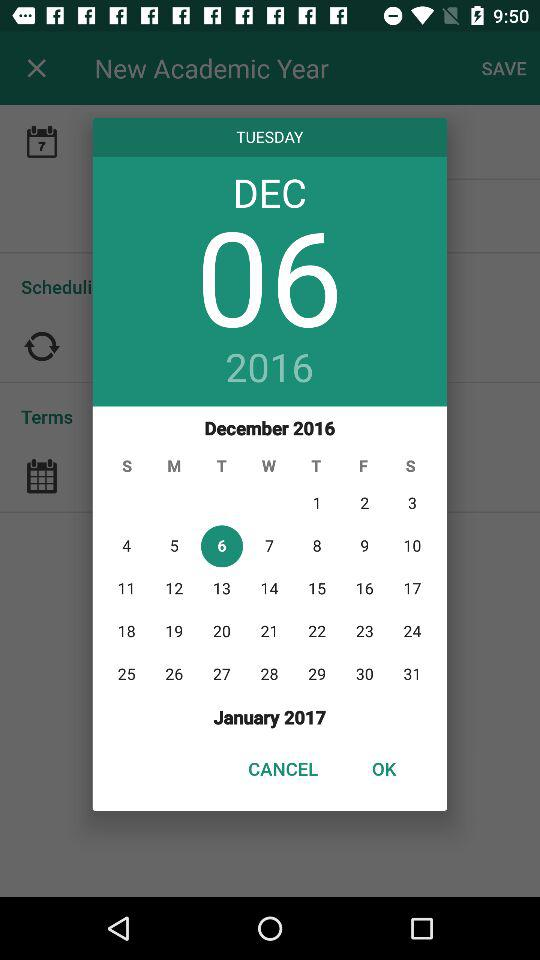What is the day on December 6? The day is Tuesday. 